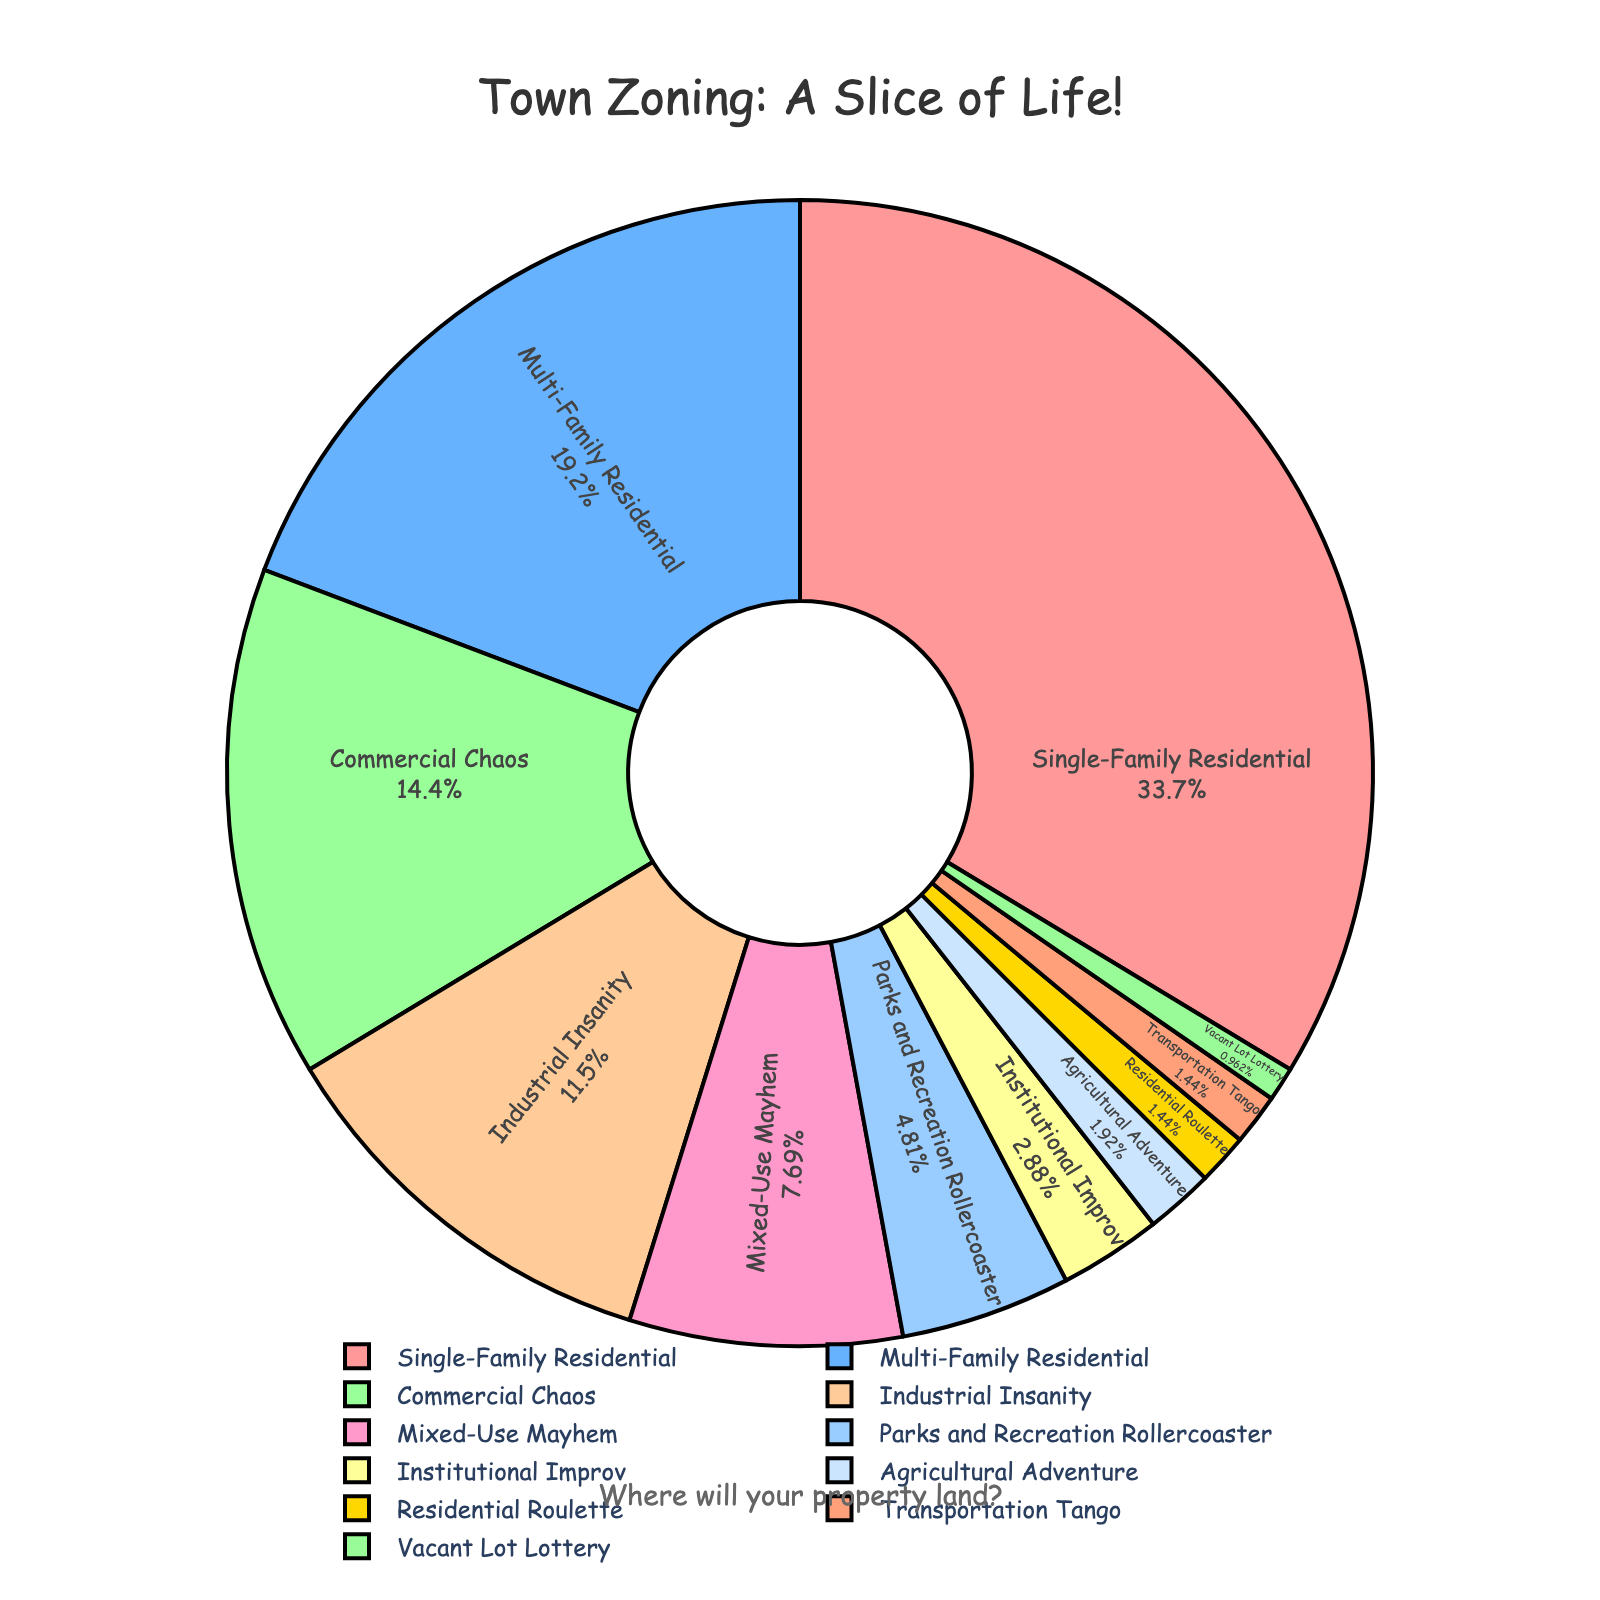What's the combined percentage of 'Residential Roulette' and 'Vacant Lot Lottery'? To get the combined percentage, add the percentages of 'Residential Roulette' (1.5%) and 'Vacant Lot Lottery' (1%). 1.5% + 1% = 2.5%
Answer: 2.5% Which zoning type takes up the largest slice in the chart? By looking at the chart, the 'Single-Family Residential' section takes up the largest slice with a percentage of 35%.
Answer: Single-Family Residential Compare 'Commercial Chaos' and 'Parks and Recreation Rollercoaster'. Which zoning type has a higher percentage, and by how much? 'Commercial Chaos' has 15% while 'Parks and Recreation Rollercoaster' has 5%. Subtract 5% from 15% to find the difference. 15% - 5% = 10%
Answer: Commercial Chaos; 10% What is the color of the section representing 'Industrial Insanity'? By inspecting the visual color scheme, 'Industrial Insanity' is represented by a shade of green.
Answer: Green Determine the total percentage for all residential zoning types combined. Add the percentages of 'Single-Family Residential' (35%), 'Multi-Family Residential' (20%), and 'Residential Roulette' (1.5%). 35% + 20% + 1.5% = 56.5%
Answer: 56.5% Which zoning types have the exact same percentage, and what is that percentage? Both 'Residential Roulette' and 'Transportation Tango' have the same percentage of 1.5%.
Answer: Residential Roulette and Transportation Tango; 1.5% How much larger is the percentage of 'Mixed-Use Mayhem' compared to 'Institutional Improv'? 'Mixed-Use Mayhem' has 8% while 'Institutional Improv' has 3%. Subtract 3% from 8% to find the difference. 8% - 3% = 5%
Answer: 5% What is the smallest zoning type shown in the pie chart, and what percentage does it represent? The chart shows 'Vacant Lot Lottery' as the smallest segment, representing 1%.
Answer: Vacant Lot Lottery; 1% If we combine 'Commercial Chaos' and 'Mixed-Use Mayhem', would their total percentage surpass that of 'Multi-Family Residential'? 'Commercial Chaos' has 15% and 'Mixed-Use Mayhem' has 8%. Adding them together, 15% + 8% = 23%. 'Multi-Family Residential' has 20%. Since 23% is greater than 20%, yes, it surpasses.
Answer: Yes; 23% > 20% Identify the zoning type that is represented in a yellow slice. 'Parks and Recreation Rollercoaster' is denoted by a yellow slice in the pie chart.
Answer: Parks and Recreation Rollercoaster 